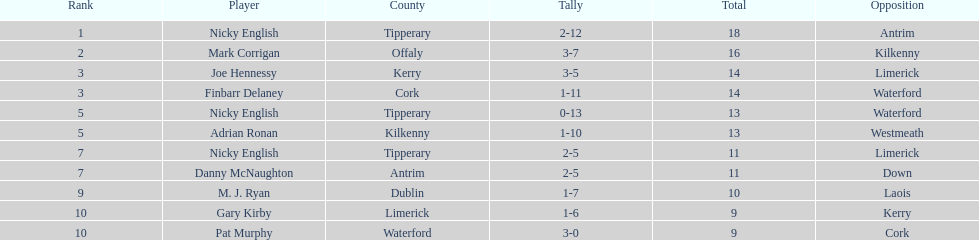Which player holds the highest ranking? Nicky English. 